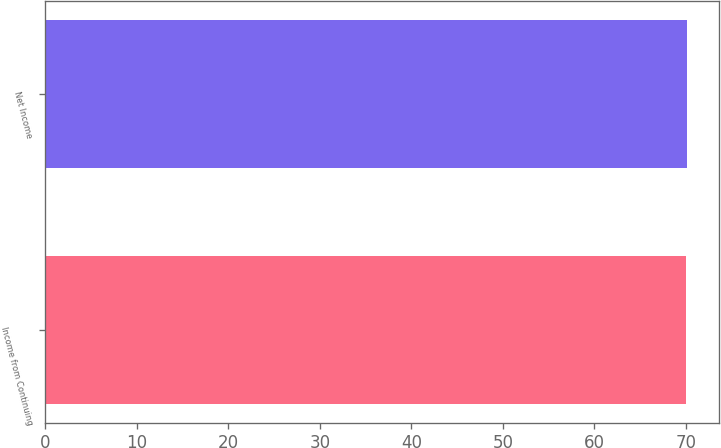<chart> <loc_0><loc_0><loc_500><loc_500><bar_chart><fcel>Income from Continuing<fcel>Net Income<nl><fcel>70<fcel>70.1<nl></chart> 